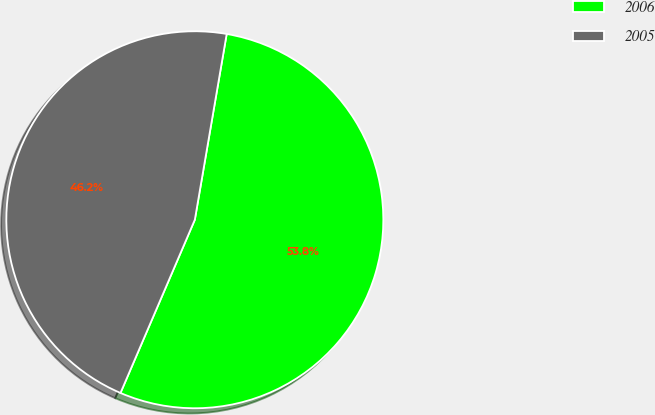<chart> <loc_0><loc_0><loc_500><loc_500><pie_chart><fcel>2006<fcel>2005<nl><fcel>53.75%<fcel>46.25%<nl></chart> 